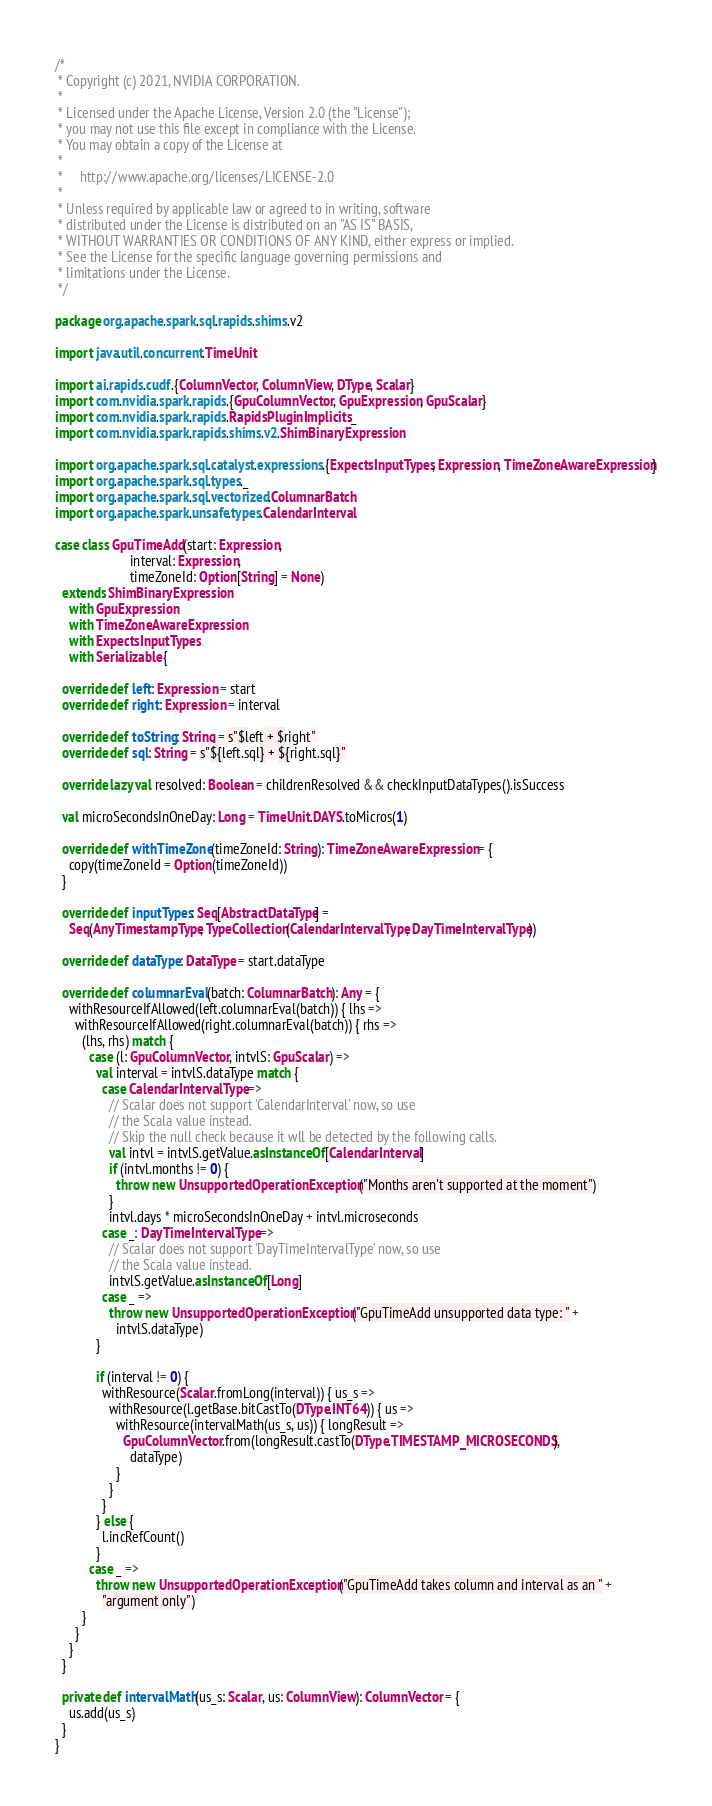Convert code to text. <code><loc_0><loc_0><loc_500><loc_500><_Scala_>/*
 * Copyright (c) 2021, NVIDIA CORPORATION.
 *
 * Licensed under the Apache License, Version 2.0 (the "License");
 * you may not use this file except in compliance with the License.
 * You may obtain a copy of the License at
 *
 *     http://www.apache.org/licenses/LICENSE-2.0
 *
 * Unless required by applicable law or agreed to in writing, software
 * distributed under the License is distributed on an "AS IS" BASIS,
 * WITHOUT WARRANTIES OR CONDITIONS OF ANY KIND, either express or implied.
 * See the License for the specific language governing permissions and
 * limitations under the License.
 */

package org.apache.spark.sql.rapids.shims.v2

import java.util.concurrent.TimeUnit

import ai.rapids.cudf.{ColumnVector, ColumnView, DType, Scalar}
import com.nvidia.spark.rapids.{GpuColumnVector, GpuExpression, GpuScalar}
import com.nvidia.spark.rapids.RapidsPluginImplicits._
import com.nvidia.spark.rapids.shims.v2.ShimBinaryExpression

import org.apache.spark.sql.catalyst.expressions.{ExpectsInputTypes, Expression, TimeZoneAwareExpression}
import org.apache.spark.sql.types._
import org.apache.spark.sql.vectorized.ColumnarBatch
import org.apache.spark.unsafe.types.CalendarInterval

case class GpuTimeAdd(start: Expression,
                      interval: Expression,
                      timeZoneId: Option[String] = None)
  extends ShimBinaryExpression
    with GpuExpression
    with TimeZoneAwareExpression
    with ExpectsInputTypes
    with Serializable {

  override def left: Expression = start
  override def right: Expression = interval

  override def toString: String = s"$left + $right"
  override def sql: String = s"${left.sql} + ${right.sql}"

  override lazy val resolved: Boolean = childrenResolved && checkInputDataTypes().isSuccess

  val microSecondsInOneDay: Long = TimeUnit.DAYS.toMicros(1)

  override def withTimeZone(timeZoneId: String): TimeZoneAwareExpression = {
    copy(timeZoneId = Option(timeZoneId))
  }

  override def inputTypes: Seq[AbstractDataType] =
    Seq(AnyTimestampType, TypeCollection(CalendarIntervalType, DayTimeIntervalType))

  override def dataType: DataType = start.dataType

  override def columnarEval(batch: ColumnarBatch): Any = {
    withResourceIfAllowed(left.columnarEval(batch)) { lhs =>
      withResourceIfAllowed(right.columnarEval(batch)) { rhs =>
        (lhs, rhs) match {
          case (l: GpuColumnVector, intvlS: GpuScalar) =>
            val interval = intvlS.dataType match {
              case CalendarIntervalType =>
                // Scalar does not support 'CalendarInterval' now, so use
                // the Scala value instead.
                // Skip the null check because it wll be detected by the following calls.
                val intvl = intvlS.getValue.asInstanceOf[CalendarInterval]
                if (intvl.months != 0) {
                  throw new UnsupportedOperationException("Months aren't supported at the moment")
                }
                intvl.days * microSecondsInOneDay + intvl.microseconds
              case _: DayTimeIntervalType =>
                // Scalar does not support 'DayTimeIntervalType' now, so use
                // the Scala value instead.
                intvlS.getValue.asInstanceOf[Long]
              case _ =>
                throw new UnsupportedOperationException("GpuTimeAdd unsupported data type: " +
                  intvlS.dataType)
            }

            if (interval != 0) {
              withResource(Scalar.fromLong(interval)) { us_s =>
                withResource(l.getBase.bitCastTo(DType.INT64)) { us =>
                  withResource(intervalMath(us_s, us)) { longResult =>
                    GpuColumnVector.from(longResult.castTo(DType.TIMESTAMP_MICROSECONDS),
                      dataType)
                  }
                }
              }
            } else {
              l.incRefCount()
            }
          case _ =>
            throw new UnsupportedOperationException("GpuTimeAdd takes column and interval as an " +
              "argument only")
        }
      }
    }
  }

  private def intervalMath(us_s: Scalar, us: ColumnView): ColumnVector = {
    us.add(us_s)
  }
}
</code> 